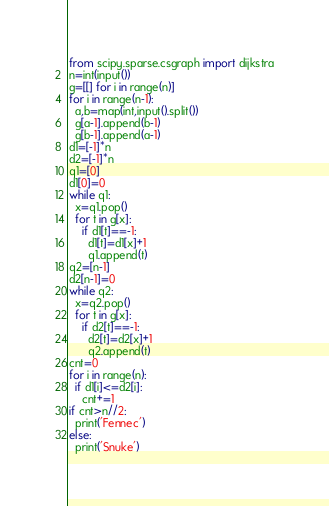<code> <loc_0><loc_0><loc_500><loc_500><_Python_>from scipy.sparse.csgraph import dijkstra
n=int(input())
g=[[] for i in range(n)]
for i in range(n-1):
  a,b=map(int,input().split())
  g[a-1].append(b-1)
  g[b-1].append(a-1)
d1=[-1]*n
d2=[-1]*n
q1=[0]
d1[0]=0
while q1:
  x=q1.pop()
  for t in g[x]:
    if d1[t]==-1:
      d1[t]=d1[x]+1
      q1.append(t)
q2=[n-1]
d2[n-1]=0
while q2:
  x=q2.pop()
  for t in g[x]:
    if d2[t]==-1:
      d2[t]=d2[x]+1
      q2.append(t)
cnt=0
for i in range(n):
  if d1[i]<=d2[i]:
    cnt+=1
if cnt>n//2:
  print('Fennec')
else:
  print('Snuke')</code> 